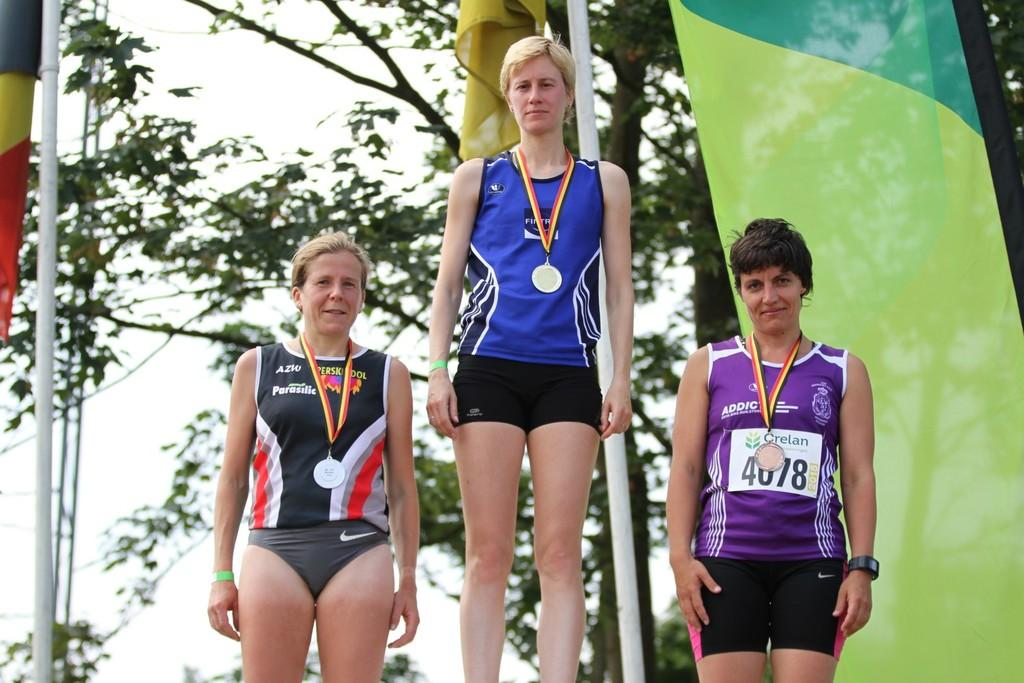<image>
Create a compact narrative representing the image presented. Three women stand wearing medals, the one furthest to the right has the word addict on her purple shirt. 